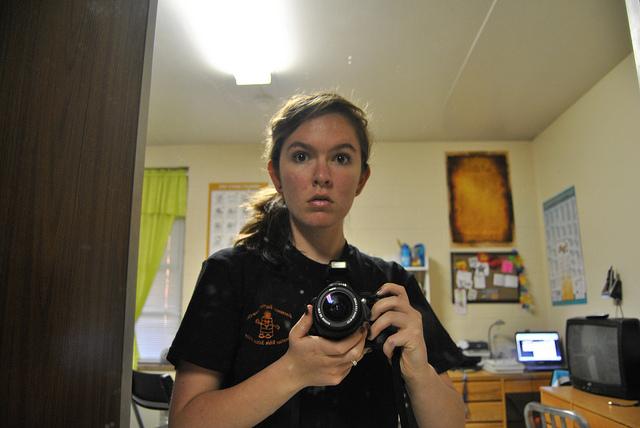How many toothbrushes are shown?
Write a very short answer. 0. What Is she holding in her right hand?
Short answer required. Camera. What room is in the background?
Give a very brief answer. Bedroom. Is the woman playing a game?
Write a very short answer. No. Who is in the pictures on the wall?
Give a very brief answer. No one. Are they going to shoot something?
Answer briefly. Yes. What is the person touching?
Keep it brief. Camera. Is this person happy?
Answer briefly. No. Is anyone in this photo wearing glasses?
Short answer required. No. What room is this?
Write a very short answer. Bedroom. What color are the walls?
Give a very brief answer. White. Does the woman look annoyed?
Quick response, please. No. Where's the camera in this picture?
Concise answer only. Hand. Is the girl playing?
Keep it brief. No. Is this woman happy?
Concise answer only. No. What is on the woman's left arm?
Be succinct. Camera. What is the woman doing with her right hand?
Give a very brief answer. Holding camera. What is in her left hand?
Concise answer only. Camera. What's the woman holding?
Answer briefly. Camera. Which hand is holding the camera?
Write a very short answer. Right. Is the woman in motion?
Give a very brief answer. No. Is she wearing glasses?
Concise answer only. No. Who is standing?
Give a very brief answer. Girl. What color is the lady's top?
Answer briefly. Black. What is the lady holding in her right hand?
Write a very short answer. Camera. Is this a selfie?
Answer briefly. Yes. What is the woman's facial expression?
Keep it brief. Surprise. What is the woman holding?
Write a very short answer. Camera. What is the person holding?
Quick response, please. Camera. What is she wearing around her neck?
Answer briefly. Camera. Does she have long hair?
Give a very brief answer. Yes. What date is on the picture?
Be succinct. 0. What room of the house is she in?
Be succinct. Bedroom. What is the woman making?
Write a very short answer. Photos. What color is the shirt?
Be succinct. Black. Is the woman smiling?
Keep it brief. No. Is the man wearing glasses?
Answer briefly. No. Is the woman wearing glasses?
Quick response, please. No. What is in her hand?
Keep it brief. Camera. Is the TV on?
Give a very brief answer. No. 